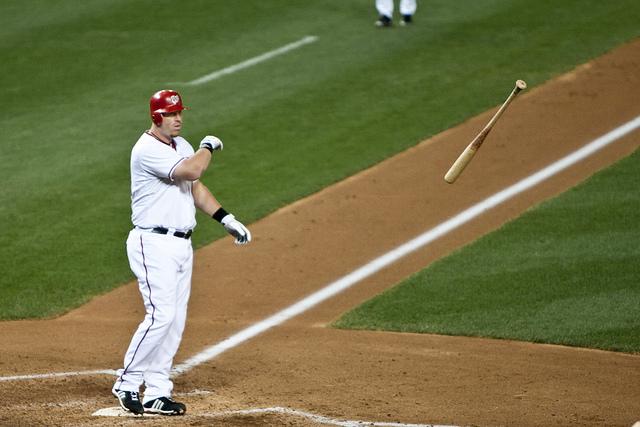What did the man just throw?
Write a very short answer. Bat. What game are they playing?
Write a very short answer. Baseball. What position is the player in front playing?
Answer briefly. Batter. Is the batter touching home plate?
Short answer required. Yes. What color is the player's helmet?
Write a very short answer. Red. What color is the batter's helmet?
Concise answer only. Red. How many players are there?
Write a very short answer. 1. What is being thrown in the picture?
Quick response, please. Bat. What has happened to the bat?
Short answer required. Thrown. 